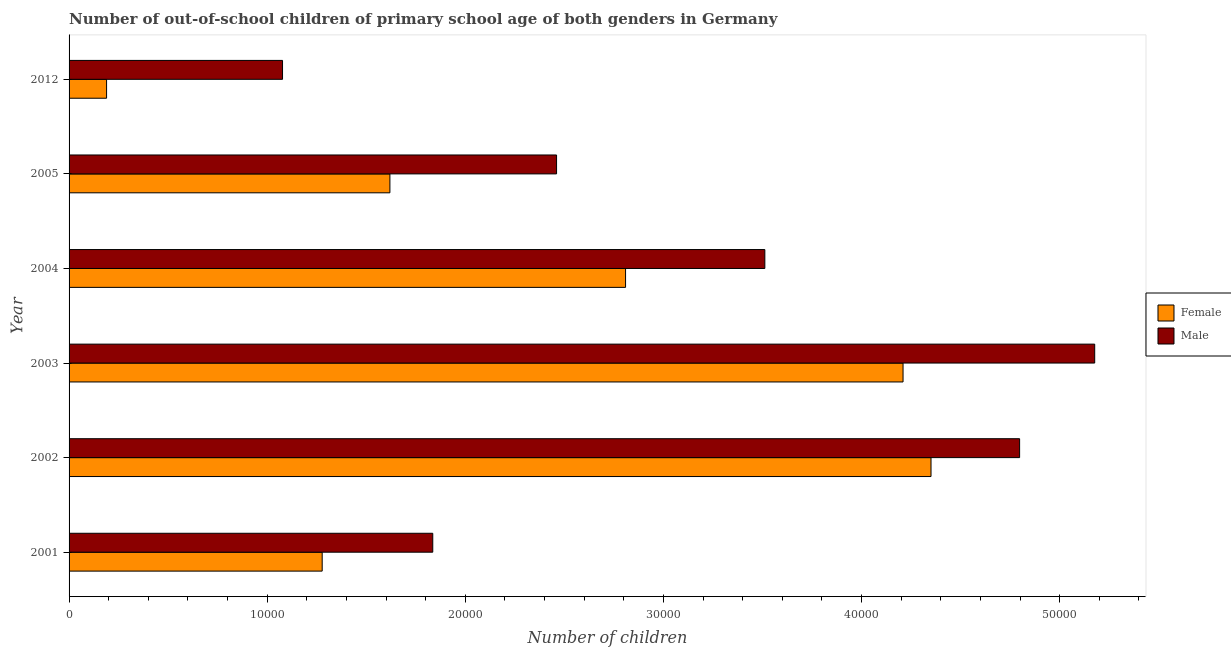How many different coloured bars are there?
Your answer should be very brief. 2. Are the number of bars on each tick of the Y-axis equal?
Offer a very short reply. Yes. How many bars are there on the 4th tick from the top?
Provide a succinct answer. 2. How many bars are there on the 2nd tick from the bottom?
Offer a terse response. 2. What is the label of the 2nd group of bars from the top?
Keep it short and to the point. 2005. In how many cases, is the number of bars for a given year not equal to the number of legend labels?
Keep it short and to the point. 0. What is the number of male out-of-school students in 2012?
Offer a terse response. 1.08e+04. Across all years, what is the maximum number of female out-of-school students?
Keep it short and to the point. 4.35e+04. Across all years, what is the minimum number of female out-of-school students?
Your response must be concise. 1893. In which year was the number of male out-of-school students maximum?
Offer a very short reply. 2003. What is the total number of female out-of-school students in the graph?
Provide a short and direct response. 1.45e+05. What is the difference between the number of male out-of-school students in 2004 and that in 2012?
Your response must be concise. 2.43e+04. What is the difference between the number of male out-of-school students in 2004 and the number of female out-of-school students in 2012?
Offer a very short reply. 3.32e+04. What is the average number of female out-of-school students per year?
Your answer should be compact. 2.41e+04. In the year 2002, what is the difference between the number of male out-of-school students and number of female out-of-school students?
Provide a succinct answer. 4472. In how many years, is the number of female out-of-school students greater than 22000 ?
Your answer should be very brief. 3. What is the ratio of the number of female out-of-school students in 2001 to that in 2005?
Provide a short and direct response. 0.79. Is the difference between the number of male out-of-school students in 2003 and 2012 greater than the difference between the number of female out-of-school students in 2003 and 2012?
Offer a terse response. Yes. What is the difference between the highest and the second highest number of female out-of-school students?
Ensure brevity in your answer.  1411. What is the difference between the highest and the lowest number of female out-of-school students?
Provide a succinct answer. 4.16e+04. Is the sum of the number of female out-of-school students in 2001 and 2003 greater than the maximum number of male out-of-school students across all years?
Make the answer very short. Yes. How many bars are there?
Make the answer very short. 12. Are all the bars in the graph horizontal?
Offer a very short reply. Yes. What is the difference between two consecutive major ticks on the X-axis?
Your answer should be very brief. 10000. Are the values on the major ticks of X-axis written in scientific E-notation?
Your response must be concise. No. Does the graph contain any zero values?
Offer a terse response. No. Does the graph contain grids?
Make the answer very short. No. What is the title of the graph?
Give a very brief answer. Number of out-of-school children of primary school age of both genders in Germany. What is the label or title of the X-axis?
Offer a terse response. Number of children. What is the label or title of the Y-axis?
Give a very brief answer. Year. What is the Number of children of Female in 2001?
Your answer should be very brief. 1.28e+04. What is the Number of children of Male in 2001?
Make the answer very short. 1.84e+04. What is the Number of children of Female in 2002?
Your response must be concise. 4.35e+04. What is the Number of children of Male in 2002?
Offer a very short reply. 4.80e+04. What is the Number of children of Female in 2003?
Your response must be concise. 4.21e+04. What is the Number of children of Male in 2003?
Your answer should be compact. 5.18e+04. What is the Number of children in Female in 2004?
Keep it short and to the point. 2.81e+04. What is the Number of children in Male in 2004?
Offer a terse response. 3.51e+04. What is the Number of children of Female in 2005?
Give a very brief answer. 1.62e+04. What is the Number of children of Male in 2005?
Offer a terse response. 2.46e+04. What is the Number of children in Female in 2012?
Provide a succinct answer. 1893. What is the Number of children in Male in 2012?
Offer a terse response. 1.08e+04. Across all years, what is the maximum Number of children of Female?
Keep it short and to the point. 4.35e+04. Across all years, what is the maximum Number of children of Male?
Your answer should be compact. 5.18e+04. Across all years, what is the minimum Number of children in Female?
Make the answer very short. 1893. Across all years, what is the minimum Number of children in Male?
Your response must be concise. 1.08e+04. What is the total Number of children of Female in the graph?
Make the answer very short. 1.45e+05. What is the total Number of children of Male in the graph?
Keep it short and to the point. 1.89e+05. What is the difference between the Number of children in Female in 2001 and that in 2002?
Ensure brevity in your answer.  -3.07e+04. What is the difference between the Number of children in Male in 2001 and that in 2002?
Your answer should be compact. -2.96e+04. What is the difference between the Number of children in Female in 2001 and that in 2003?
Provide a succinct answer. -2.93e+04. What is the difference between the Number of children of Male in 2001 and that in 2003?
Keep it short and to the point. -3.34e+04. What is the difference between the Number of children of Female in 2001 and that in 2004?
Give a very brief answer. -1.53e+04. What is the difference between the Number of children in Male in 2001 and that in 2004?
Ensure brevity in your answer.  -1.68e+04. What is the difference between the Number of children in Female in 2001 and that in 2005?
Your response must be concise. -3418. What is the difference between the Number of children of Male in 2001 and that in 2005?
Your answer should be very brief. -6249. What is the difference between the Number of children of Female in 2001 and that in 2012?
Your answer should be very brief. 1.09e+04. What is the difference between the Number of children of Male in 2001 and that in 2012?
Your answer should be very brief. 7583. What is the difference between the Number of children in Female in 2002 and that in 2003?
Make the answer very short. 1411. What is the difference between the Number of children of Male in 2002 and that in 2003?
Your answer should be compact. -3790. What is the difference between the Number of children of Female in 2002 and that in 2004?
Ensure brevity in your answer.  1.54e+04. What is the difference between the Number of children in Male in 2002 and that in 2004?
Make the answer very short. 1.29e+04. What is the difference between the Number of children of Female in 2002 and that in 2005?
Provide a short and direct response. 2.73e+04. What is the difference between the Number of children in Male in 2002 and that in 2005?
Provide a short and direct response. 2.34e+04. What is the difference between the Number of children in Female in 2002 and that in 2012?
Ensure brevity in your answer.  4.16e+04. What is the difference between the Number of children of Male in 2002 and that in 2012?
Your answer should be very brief. 3.72e+04. What is the difference between the Number of children in Female in 2003 and that in 2004?
Give a very brief answer. 1.40e+04. What is the difference between the Number of children in Male in 2003 and that in 2004?
Ensure brevity in your answer.  1.66e+04. What is the difference between the Number of children in Female in 2003 and that in 2005?
Offer a very short reply. 2.59e+04. What is the difference between the Number of children in Male in 2003 and that in 2005?
Offer a terse response. 2.72e+04. What is the difference between the Number of children of Female in 2003 and that in 2012?
Offer a very short reply. 4.02e+04. What is the difference between the Number of children in Male in 2003 and that in 2012?
Keep it short and to the point. 4.10e+04. What is the difference between the Number of children in Female in 2004 and that in 2005?
Keep it short and to the point. 1.19e+04. What is the difference between the Number of children of Male in 2004 and that in 2005?
Offer a very short reply. 1.05e+04. What is the difference between the Number of children in Female in 2004 and that in 2012?
Provide a succinct answer. 2.62e+04. What is the difference between the Number of children of Male in 2004 and that in 2012?
Offer a terse response. 2.43e+04. What is the difference between the Number of children in Female in 2005 and that in 2012?
Your answer should be very brief. 1.43e+04. What is the difference between the Number of children in Male in 2005 and that in 2012?
Give a very brief answer. 1.38e+04. What is the difference between the Number of children of Female in 2001 and the Number of children of Male in 2002?
Your answer should be compact. -3.52e+04. What is the difference between the Number of children in Female in 2001 and the Number of children in Male in 2003?
Keep it short and to the point. -3.90e+04. What is the difference between the Number of children in Female in 2001 and the Number of children in Male in 2004?
Your answer should be very brief. -2.23e+04. What is the difference between the Number of children in Female in 2001 and the Number of children in Male in 2005?
Make the answer very short. -1.18e+04. What is the difference between the Number of children of Female in 2001 and the Number of children of Male in 2012?
Provide a succinct answer. 2002. What is the difference between the Number of children in Female in 2002 and the Number of children in Male in 2003?
Provide a succinct answer. -8262. What is the difference between the Number of children of Female in 2002 and the Number of children of Male in 2004?
Give a very brief answer. 8387. What is the difference between the Number of children in Female in 2002 and the Number of children in Male in 2005?
Your answer should be very brief. 1.89e+04. What is the difference between the Number of children in Female in 2002 and the Number of children in Male in 2012?
Offer a very short reply. 3.27e+04. What is the difference between the Number of children of Female in 2003 and the Number of children of Male in 2004?
Give a very brief answer. 6976. What is the difference between the Number of children in Female in 2003 and the Number of children in Male in 2005?
Keep it short and to the point. 1.75e+04. What is the difference between the Number of children of Female in 2003 and the Number of children of Male in 2012?
Provide a succinct answer. 3.13e+04. What is the difference between the Number of children in Female in 2004 and the Number of children in Male in 2005?
Offer a very short reply. 3483. What is the difference between the Number of children of Female in 2004 and the Number of children of Male in 2012?
Keep it short and to the point. 1.73e+04. What is the difference between the Number of children in Female in 2005 and the Number of children in Male in 2012?
Your answer should be compact. 5420. What is the average Number of children of Female per year?
Your response must be concise. 2.41e+04. What is the average Number of children in Male per year?
Your answer should be compact. 3.14e+04. In the year 2001, what is the difference between the Number of children of Female and Number of children of Male?
Provide a short and direct response. -5581. In the year 2002, what is the difference between the Number of children of Female and Number of children of Male?
Make the answer very short. -4472. In the year 2003, what is the difference between the Number of children of Female and Number of children of Male?
Offer a very short reply. -9673. In the year 2004, what is the difference between the Number of children in Female and Number of children in Male?
Offer a very short reply. -7030. In the year 2005, what is the difference between the Number of children of Female and Number of children of Male?
Your response must be concise. -8412. In the year 2012, what is the difference between the Number of children in Female and Number of children in Male?
Offer a terse response. -8881. What is the ratio of the Number of children in Female in 2001 to that in 2002?
Your answer should be compact. 0.29. What is the ratio of the Number of children in Male in 2001 to that in 2002?
Keep it short and to the point. 0.38. What is the ratio of the Number of children in Female in 2001 to that in 2003?
Your answer should be very brief. 0.3. What is the ratio of the Number of children in Male in 2001 to that in 2003?
Ensure brevity in your answer.  0.35. What is the ratio of the Number of children of Female in 2001 to that in 2004?
Offer a very short reply. 0.45. What is the ratio of the Number of children in Male in 2001 to that in 2004?
Your answer should be very brief. 0.52. What is the ratio of the Number of children in Female in 2001 to that in 2005?
Your answer should be compact. 0.79. What is the ratio of the Number of children of Male in 2001 to that in 2005?
Your answer should be very brief. 0.75. What is the ratio of the Number of children in Female in 2001 to that in 2012?
Your answer should be very brief. 6.75. What is the ratio of the Number of children in Male in 2001 to that in 2012?
Your response must be concise. 1.7. What is the ratio of the Number of children of Female in 2002 to that in 2003?
Provide a succinct answer. 1.03. What is the ratio of the Number of children of Male in 2002 to that in 2003?
Your answer should be compact. 0.93. What is the ratio of the Number of children of Female in 2002 to that in 2004?
Provide a short and direct response. 1.55. What is the ratio of the Number of children in Male in 2002 to that in 2004?
Offer a very short reply. 1.37. What is the ratio of the Number of children of Female in 2002 to that in 2005?
Provide a short and direct response. 2.69. What is the ratio of the Number of children of Male in 2002 to that in 2005?
Your response must be concise. 1.95. What is the ratio of the Number of children of Female in 2002 to that in 2012?
Ensure brevity in your answer.  22.98. What is the ratio of the Number of children in Male in 2002 to that in 2012?
Offer a very short reply. 4.45. What is the ratio of the Number of children in Female in 2003 to that in 2004?
Provide a succinct answer. 1.5. What is the ratio of the Number of children in Male in 2003 to that in 2004?
Give a very brief answer. 1.47. What is the ratio of the Number of children of Female in 2003 to that in 2005?
Provide a succinct answer. 2.6. What is the ratio of the Number of children in Male in 2003 to that in 2005?
Offer a terse response. 2.1. What is the ratio of the Number of children in Female in 2003 to that in 2012?
Give a very brief answer. 22.24. What is the ratio of the Number of children of Male in 2003 to that in 2012?
Keep it short and to the point. 4.8. What is the ratio of the Number of children in Female in 2004 to that in 2005?
Offer a terse response. 1.73. What is the ratio of the Number of children of Male in 2004 to that in 2005?
Make the answer very short. 1.43. What is the ratio of the Number of children in Female in 2004 to that in 2012?
Give a very brief answer. 14.84. What is the ratio of the Number of children of Male in 2004 to that in 2012?
Make the answer very short. 3.26. What is the ratio of the Number of children of Female in 2005 to that in 2012?
Make the answer very short. 8.55. What is the ratio of the Number of children in Male in 2005 to that in 2012?
Keep it short and to the point. 2.28. What is the difference between the highest and the second highest Number of children in Female?
Ensure brevity in your answer.  1411. What is the difference between the highest and the second highest Number of children in Male?
Your response must be concise. 3790. What is the difference between the highest and the lowest Number of children of Female?
Give a very brief answer. 4.16e+04. What is the difference between the highest and the lowest Number of children in Male?
Keep it short and to the point. 4.10e+04. 